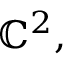Convert formula to latex. <formula><loc_0><loc_0><loc_500><loc_500>\mathbb { C } ^ { 2 } ,</formula> 